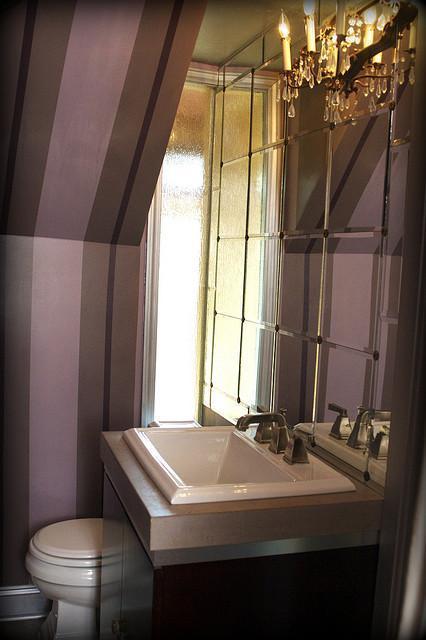How many sinks on the wall?
Give a very brief answer. 1. 